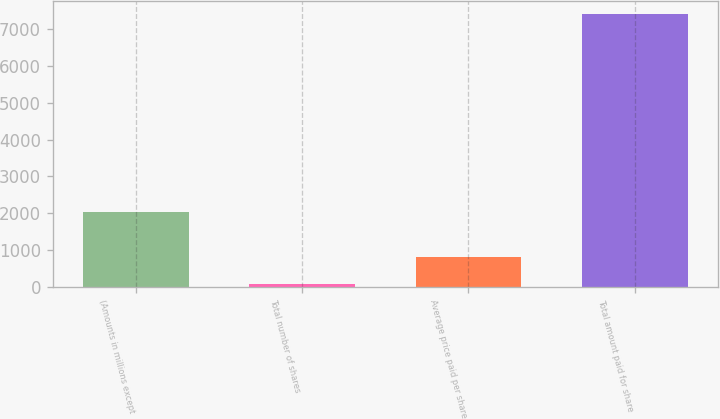Convert chart to OTSL. <chart><loc_0><loc_0><loc_500><loc_500><bar_chart><fcel>(Amounts in millions except<fcel>Total number of shares<fcel>Average price paid per share<fcel>Total amount paid for share<nl><fcel>2019<fcel>79.5<fcel>812.55<fcel>7410<nl></chart> 